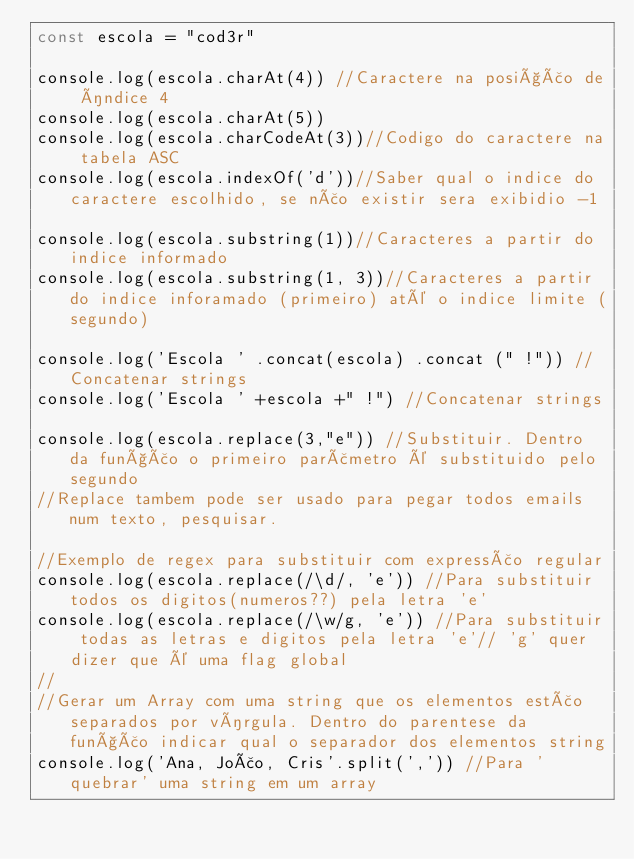<code> <loc_0><loc_0><loc_500><loc_500><_JavaScript_>const escola = "cod3r"

console.log(escola.charAt(4)) //Caractere na posição de índice 4
console.log(escola.charAt(5))
console.log(escola.charCodeAt(3))//Codigo do caractere na tabela ASC
console.log(escola.indexOf('d'))//Saber qual o indice do caractere escolhido, se não existir sera exibidio -1

console.log(escola.substring(1))//Caracteres a partir do indice informado
console.log(escola.substring(1, 3))//Caracteres a partir do indice inforamado (primeiro) até o indice limite (segundo)

console.log('Escola ' .concat(escola) .concat (" !")) //Concatenar strings
console.log('Escola ' +escola +" !") //Concatenar strings

console.log(escola.replace(3,"e")) //Substituir. Dentro da função o primeiro parãmetro é substituido pelo segundo
//Replace tambem pode ser usado para pegar todos emails num texto, pesquisar.

//Exemplo de regex para substituir com expressão regular
console.log(escola.replace(/\d/, 'e')) //Para substituir todos os digitos(numeros??) pela letra 'e'
console.log(escola.replace(/\w/g, 'e')) //Para substituir todas as letras e digitos pela letra 'e'// 'g' quer dizer que é uma flag global
//
//Gerar um Array com uma string que os elementos estão separados por vírgula. Dentro do parentese da função indicar qual o separador dos elementos string
console.log('Ana, João, Cris'.split(',')) //Para 'quebrar' uma string em um array

</code> 